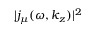<formula> <loc_0><loc_0><loc_500><loc_500>| j _ { \mu } ( \omega , k _ { z } ) | ^ { 2 }</formula> 